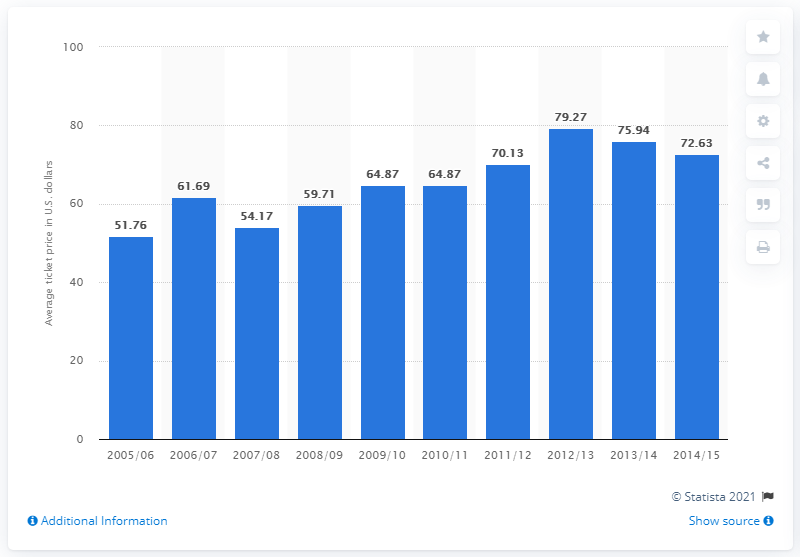Mention a couple of crucial points in this snapshot. The average ticket price for Edmonton Oilers games in the 2005/2006 season was $51.76. 